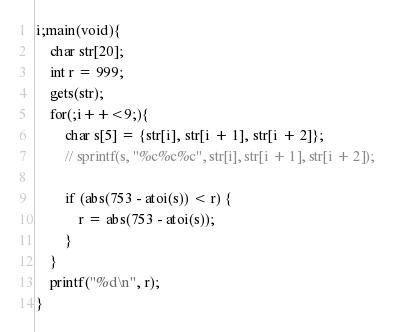Convert code to text. <code><loc_0><loc_0><loc_500><loc_500><_C_>i;main(void){
	char str[20];
	int r = 999;
	gets(str);
	for(;i++<9;){
		char s[5] = {str[i], str[i + 1], str[i + 2]};
		// sprintf(s, "%c%c%c", str[i], str[i + 1], str[i + 2]);

		if (abs(753 - atoi(s)) < r) {
			r = abs(753 - atoi(s));
		}
	}
	printf("%d\n", r);
}</code> 